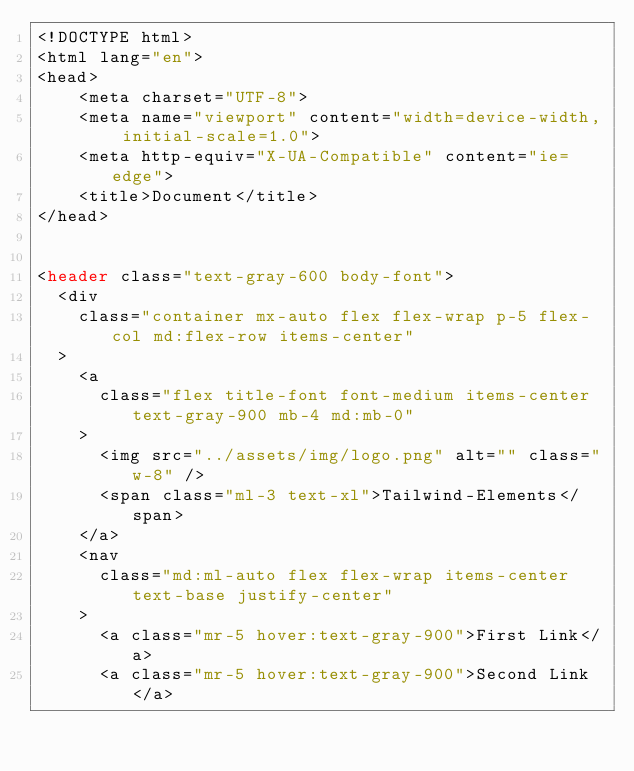Convert code to text. <code><loc_0><loc_0><loc_500><loc_500><_PHP_><!DOCTYPE html>
<html lang="en">
<head>
    <meta charset="UTF-8">
    <meta name="viewport" content="width=device-width, initial-scale=1.0">
    <meta http-equiv="X-UA-Compatible" content="ie=edge">
    <title>Document</title>
</head>


<header class="text-gray-600 body-font">
  <div
    class="container mx-auto flex flex-wrap p-5 flex-col md:flex-row items-center"
  >
    <a
      class="flex title-font font-medium items-center text-gray-900 mb-4 md:mb-0"
    >
      <img src="../assets/img/logo.png" alt="" class="w-8" />
      <span class="ml-3 text-xl">Tailwind-Elements</span>
    </a>
    <nav
      class="md:ml-auto flex flex-wrap items-center text-base justify-center"
    >
      <a class="mr-5 hover:text-gray-900">First Link</a>
      <a class="mr-5 hover:text-gray-900">Second Link</a></code> 